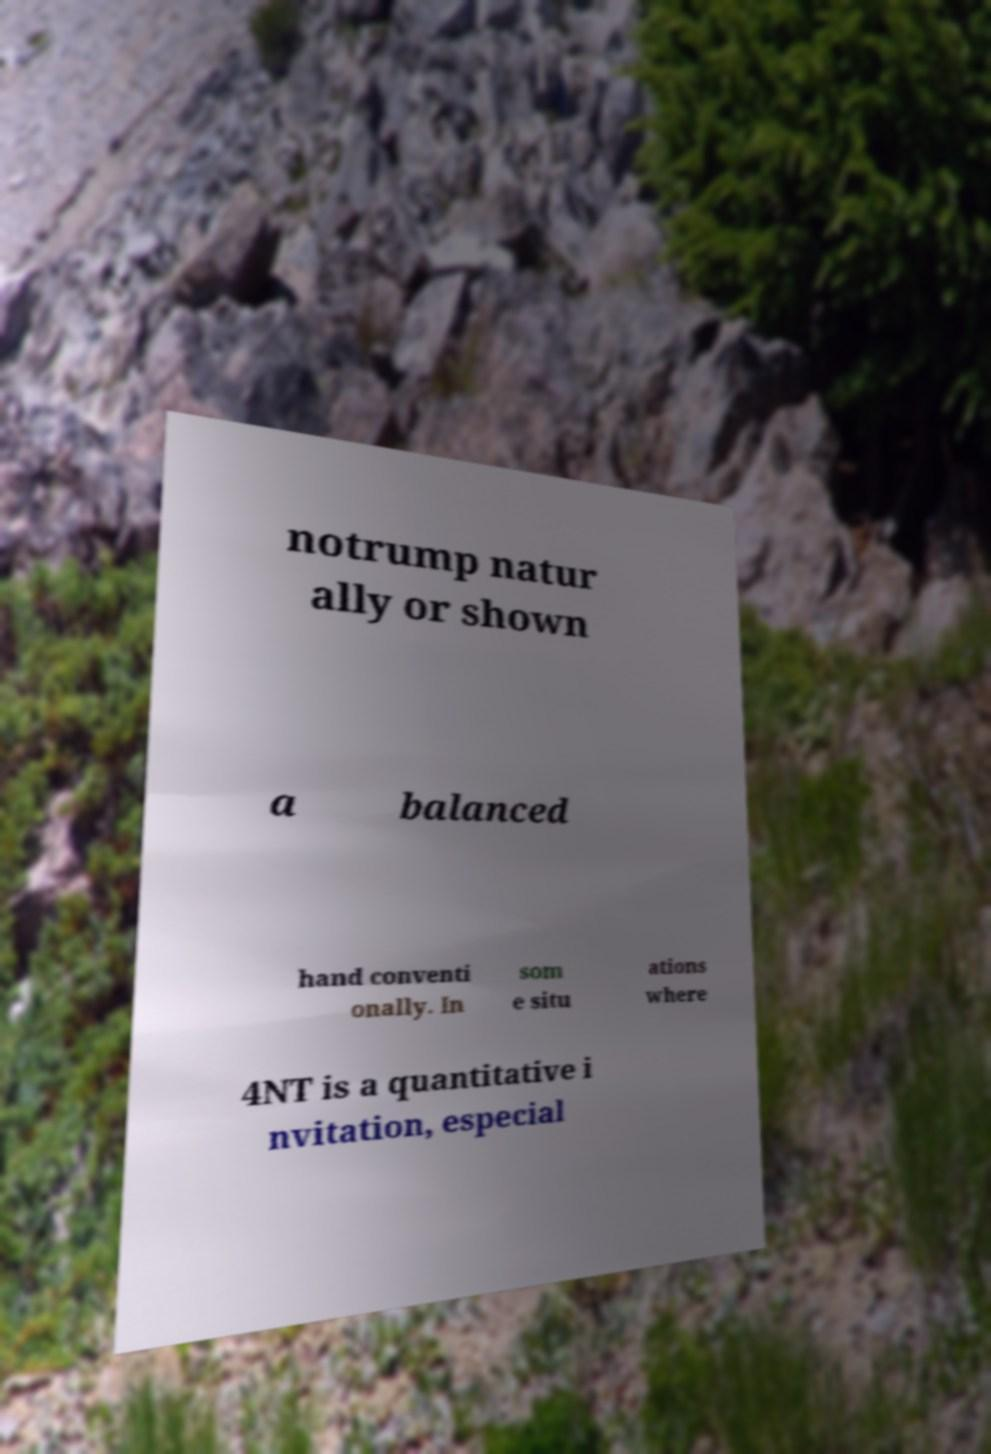Could you extract and type out the text from this image? notrump natur ally or shown a balanced hand conventi onally. In som e situ ations where 4NT is a quantitative i nvitation, especial 